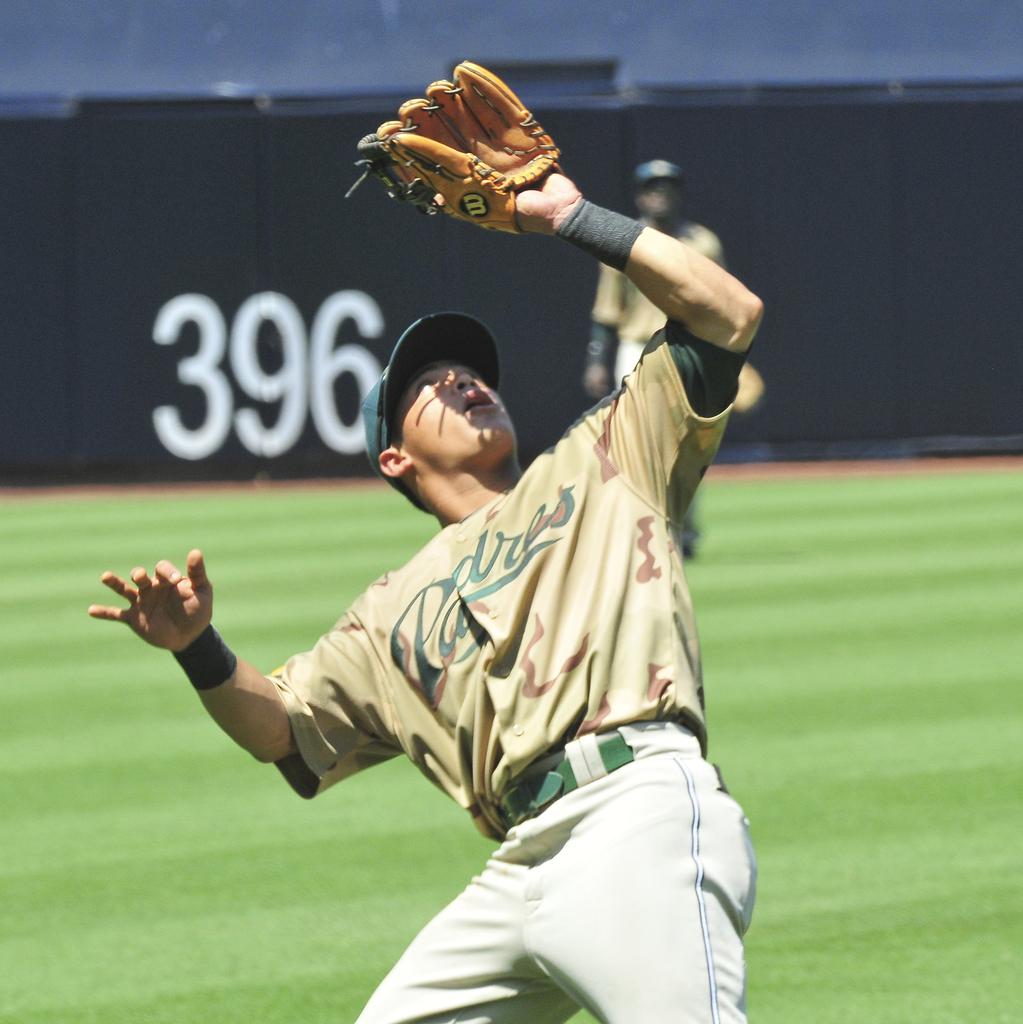What section of the field are the players in?
Provide a short and direct response. Answering does not require reading text in the image. What team does he play for?
Your response must be concise. Padres. 